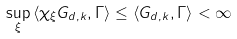Convert formula to latex. <formula><loc_0><loc_0><loc_500><loc_500>\sup _ { \xi } \, \langle \chi _ { \xi } G _ { d , k } , \Gamma \rangle \leq \langle G _ { d , k } , \Gamma \rangle < \infty</formula> 